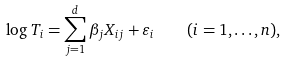Convert formula to latex. <formula><loc_0><loc_0><loc_500><loc_500>\log T _ { i } = \sum _ { j = 1 } ^ { d } \beta _ { j } X _ { i j } + \varepsilon _ { i } \quad ( i = 1 , \dots , n ) ,</formula> 